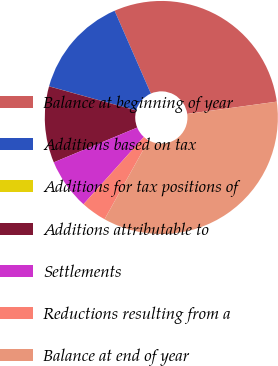Convert chart. <chart><loc_0><loc_0><loc_500><loc_500><pie_chart><fcel>Balance at beginning of year<fcel>Additions based on tax<fcel>Additions for tax positions of<fcel>Additions attributable to<fcel>Settlements<fcel>Reductions resulting from a<fcel>Balance at end of year<nl><fcel>29.4%<fcel>14.12%<fcel>0.01%<fcel>10.59%<fcel>7.07%<fcel>3.54%<fcel>35.27%<nl></chart> 